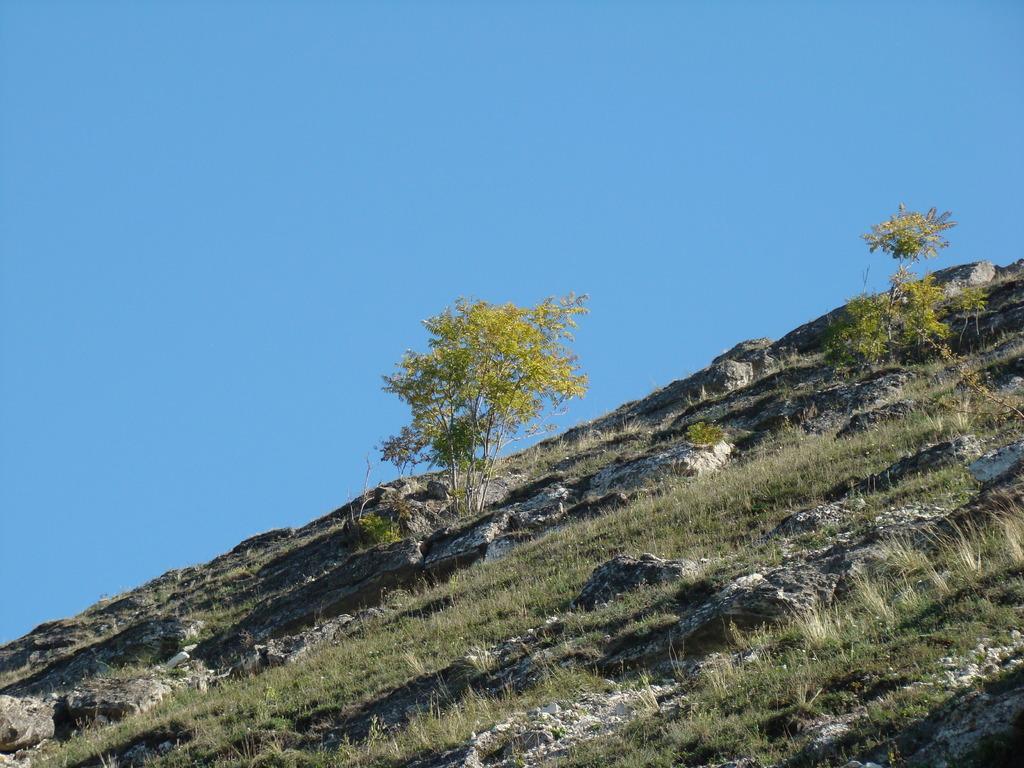Please provide a concise description of this image. This image is clicked outside. There is grass in the middle. There are trees in the middle. There is sky at the top. 